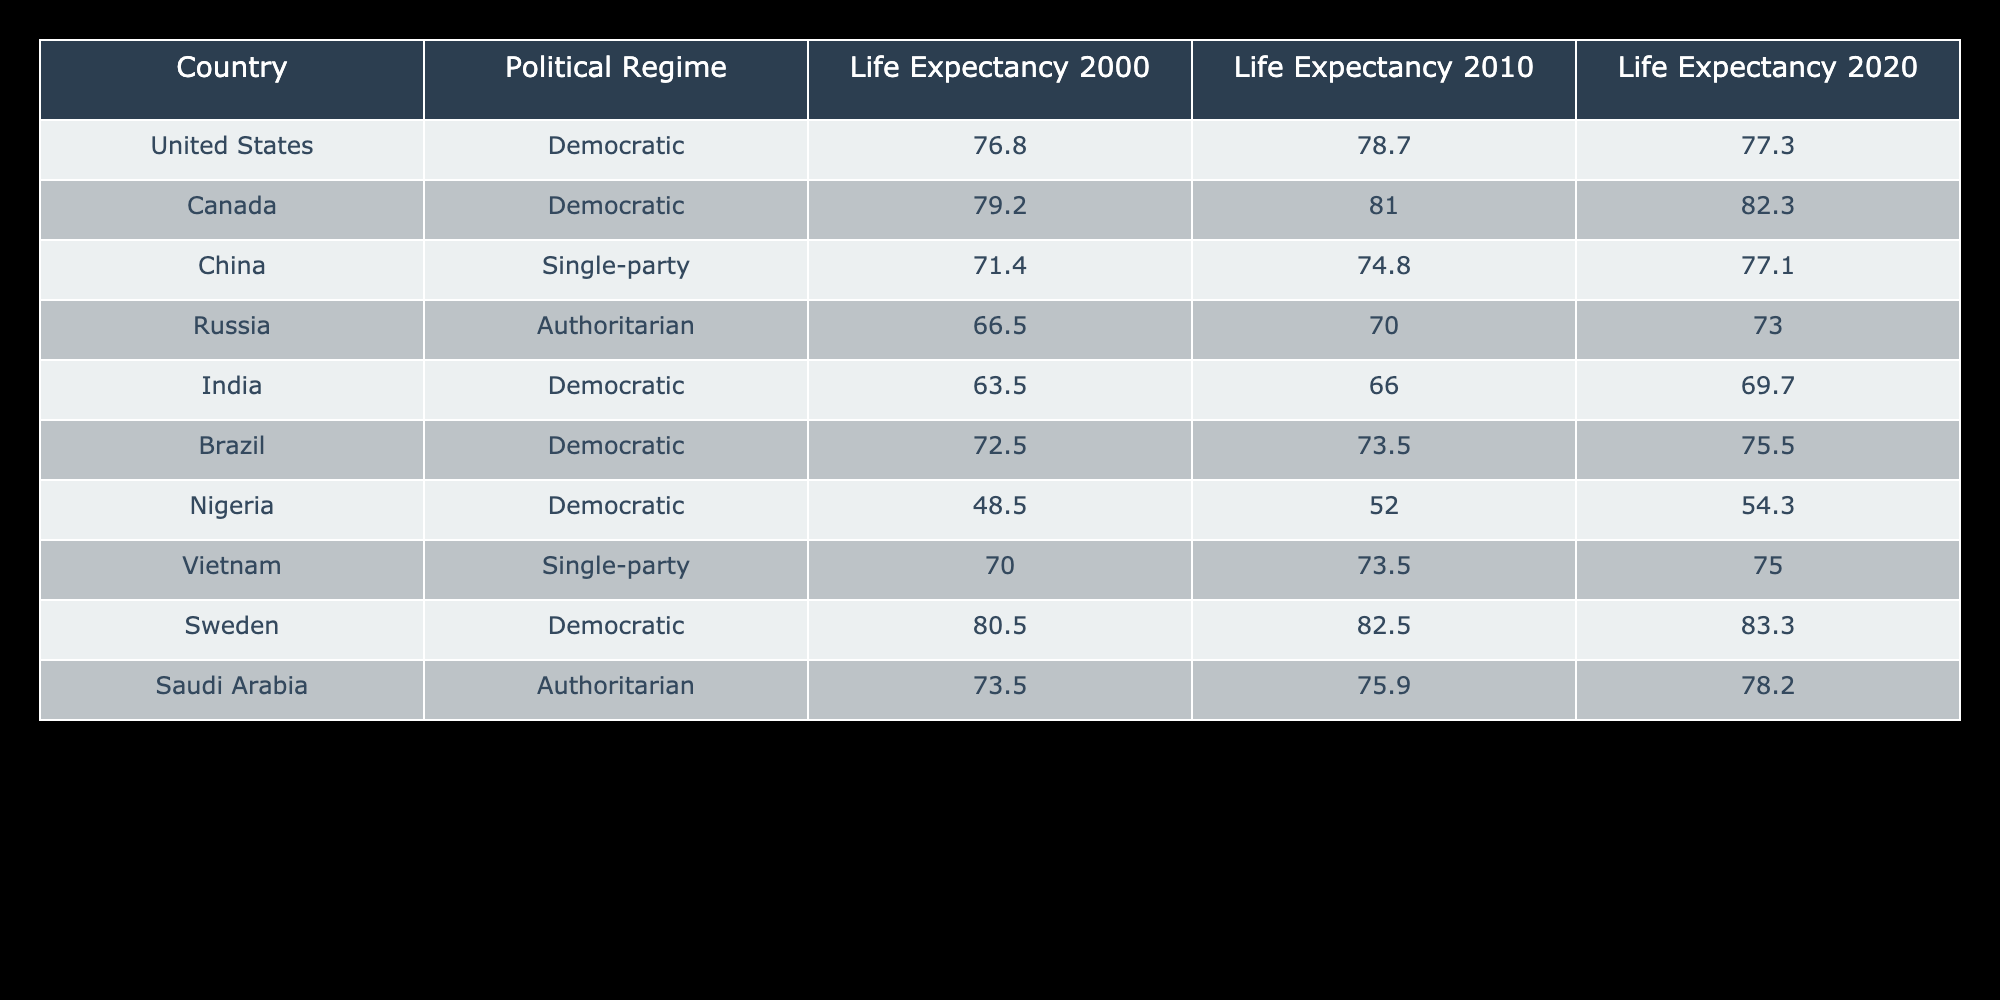What was the life expectancy in Canada in 2010? The table indicates that life expectancy in Canada for the year 2010 is listed under the corresponding column, which shows a value of 81.0 years.
Answer: 81.0 Which country had the highest life expectancy in 2020? By looking at the values for life expectancy in the year 2020, Canada (82.3) has the highest value compared to other countries.
Answer: Canada What is the difference in life expectancy between Sweden in 2000 and Saudi Arabia in 2020? The life expectancy for Sweden in 2000 was 80.5, and for Saudi Arabia in 2020, it was 78.2. The difference can be calculated as 80.5 - 78.2 = 2.3.
Answer: 2.3 Is the life expectancy in India higher in 2020 than in 2010? The life expectancy in India is 69.7 in 2020, which is higher than 66.0 in 2010. Therefore, the statement is true.
Answer: Yes Which political regime had the lowest average life expectancy across all years presented in the table? By calculating the averages for each regime: Democratic: (76.8 + 78.7 + 77.3) / 3 = 77.6, Single-party: (71.4 + 74.8 + 77.1) / 3 = 74.4, Authoritarian: (66.5 + 70.0 + 73.0) / 3 = 69.8. The Single-party regime has the lowest average life expectancy (74.4).
Answer: Single-party What was the change in life expectancy for Russia from 2000 to 2020? Russia's life expectancy in 2000 was 66.5 years and in 2020 it was 73.0 years. The change is calculated as 73.0 - 66.5 = 6.5 years.
Answer: 6.5 Is Vietnam's life expectancy consistently increasing from 2010 to 2020? Vietnam's life expectancy was 73.5 in 2010 and increased to 75.0 in 2020, indicating an increase over that period. Therefore, this statement is true.
Answer: Yes What is the average life expectancy of countries categorized as Democratic in 2020? For Democratic countries in 2020, the life expectancies are United States (77.3), Canada (82.3), India (69.7), Brazil (75.5), and Nigeria (54.3). The average is (77.3 + 82.3 + 69.7 + 75.5 + 54.3) / 5 = 71.82.
Answer: 71.82 What was the life expectancy trend in China from 2000 to 2020? China's life expectancy improved from 71.4 in 2000 to 74.8 in 2010, and then again to 77.1 in 2020, indicating a consistent upward trend over the two decades.
Answer: Upward trend 